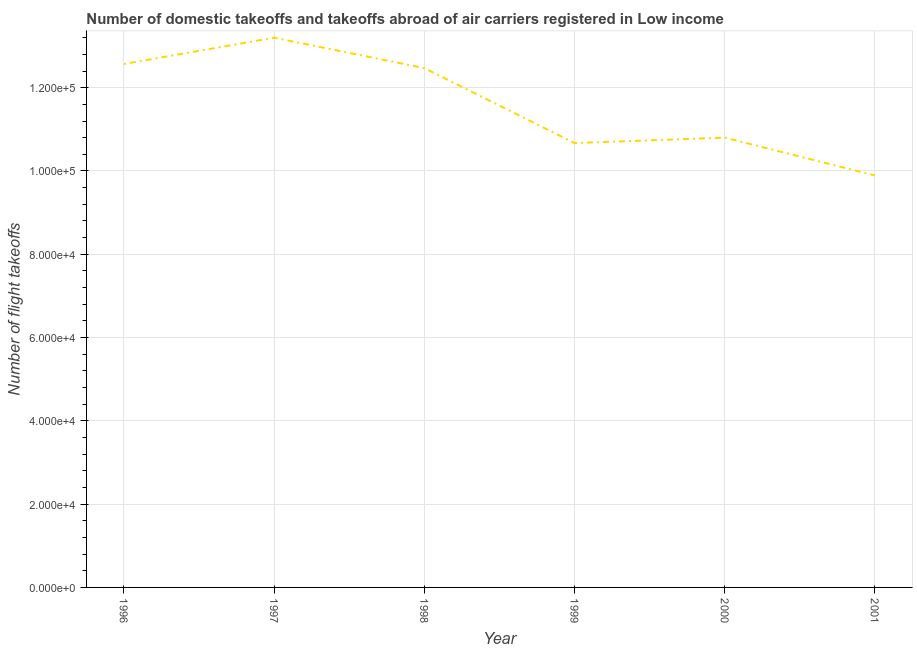What is the number of flight takeoffs in 1996?
Make the answer very short. 1.26e+05. Across all years, what is the maximum number of flight takeoffs?
Your answer should be compact. 1.32e+05. Across all years, what is the minimum number of flight takeoffs?
Provide a succinct answer. 9.89e+04. In which year was the number of flight takeoffs maximum?
Your response must be concise. 1997. In which year was the number of flight takeoffs minimum?
Offer a very short reply. 2001. What is the sum of the number of flight takeoffs?
Give a very brief answer. 6.96e+05. What is the difference between the number of flight takeoffs in 1997 and 1998?
Your answer should be very brief. 7300. What is the average number of flight takeoffs per year?
Your answer should be compact. 1.16e+05. What is the median number of flight takeoffs?
Your response must be concise. 1.16e+05. What is the ratio of the number of flight takeoffs in 2000 to that in 2001?
Make the answer very short. 1.09. What is the difference between the highest and the second highest number of flight takeoffs?
Keep it short and to the point. 6300. What is the difference between the highest and the lowest number of flight takeoffs?
Your response must be concise. 3.31e+04. Does the graph contain any zero values?
Offer a terse response. No. Does the graph contain grids?
Ensure brevity in your answer.  Yes. What is the title of the graph?
Offer a very short reply. Number of domestic takeoffs and takeoffs abroad of air carriers registered in Low income. What is the label or title of the Y-axis?
Ensure brevity in your answer.  Number of flight takeoffs. What is the Number of flight takeoffs in 1996?
Offer a terse response. 1.26e+05. What is the Number of flight takeoffs of 1997?
Offer a terse response. 1.32e+05. What is the Number of flight takeoffs of 1998?
Provide a short and direct response. 1.25e+05. What is the Number of flight takeoffs of 1999?
Keep it short and to the point. 1.07e+05. What is the Number of flight takeoffs of 2000?
Provide a short and direct response. 1.08e+05. What is the Number of flight takeoffs in 2001?
Provide a short and direct response. 9.89e+04. What is the difference between the Number of flight takeoffs in 1996 and 1997?
Give a very brief answer. -6300. What is the difference between the Number of flight takeoffs in 1996 and 1999?
Your response must be concise. 1.90e+04. What is the difference between the Number of flight takeoffs in 1996 and 2000?
Offer a terse response. 1.77e+04. What is the difference between the Number of flight takeoffs in 1996 and 2001?
Your answer should be compact. 2.68e+04. What is the difference between the Number of flight takeoffs in 1997 and 1998?
Offer a very short reply. 7300. What is the difference between the Number of flight takeoffs in 1997 and 1999?
Make the answer very short. 2.53e+04. What is the difference between the Number of flight takeoffs in 1997 and 2000?
Provide a succinct answer. 2.40e+04. What is the difference between the Number of flight takeoffs in 1997 and 2001?
Keep it short and to the point. 3.31e+04. What is the difference between the Number of flight takeoffs in 1998 and 1999?
Your answer should be very brief. 1.80e+04. What is the difference between the Number of flight takeoffs in 1998 and 2000?
Provide a succinct answer. 1.67e+04. What is the difference between the Number of flight takeoffs in 1998 and 2001?
Your response must be concise. 2.58e+04. What is the difference between the Number of flight takeoffs in 1999 and 2000?
Make the answer very short. -1307. What is the difference between the Number of flight takeoffs in 1999 and 2001?
Make the answer very short. 7775. What is the difference between the Number of flight takeoffs in 2000 and 2001?
Your answer should be compact. 9082. What is the ratio of the Number of flight takeoffs in 1996 to that in 1998?
Provide a succinct answer. 1.01. What is the ratio of the Number of flight takeoffs in 1996 to that in 1999?
Offer a terse response. 1.18. What is the ratio of the Number of flight takeoffs in 1996 to that in 2000?
Make the answer very short. 1.16. What is the ratio of the Number of flight takeoffs in 1996 to that in 2001?
Your response must be concise. 1.27. What is the ratio of the Number of flight takeoffs in 1997 to that in 1998?
Ensure brevity in your answer.  1.06. What is the ratio of the Number of flight takeoffs in 1997 to that in 1999?
Provide a succinct answer. 1.24. What is the ratio of the Number of flight takeoffs in 1997 to that in 2000?
Give a very brief answer. 1.22. What is the ratio of the Number of flight takeoffs in 1997 to that in 2001?
Make the answer very short. 1.33. What is the ratio of the Number of flight takeoffs in 1998 to that in 1999?
Offer a very short reply. 1.17. What is the ratio of the Number of flight takeoffs in 1998 to that in 2000?
Keep it short and to the point. 1.16. What is the ratio of the Number of flight takeoffs in 1998 to that in 2001?
Provide a succinct answer. 1.26. What is the ratio of the Number of flight takeoffs in 1999 to that in 2000?
Give a very brief answer. 0.99. What is the ratio of the Number of flight takeoffs in 1999 to that in 2001?
Provide a succinct answer. 1.08. What is the ratio of the Number of flight takeoffs in 2000 to that in 2001?
Provide a short and direct response. 1.09. 